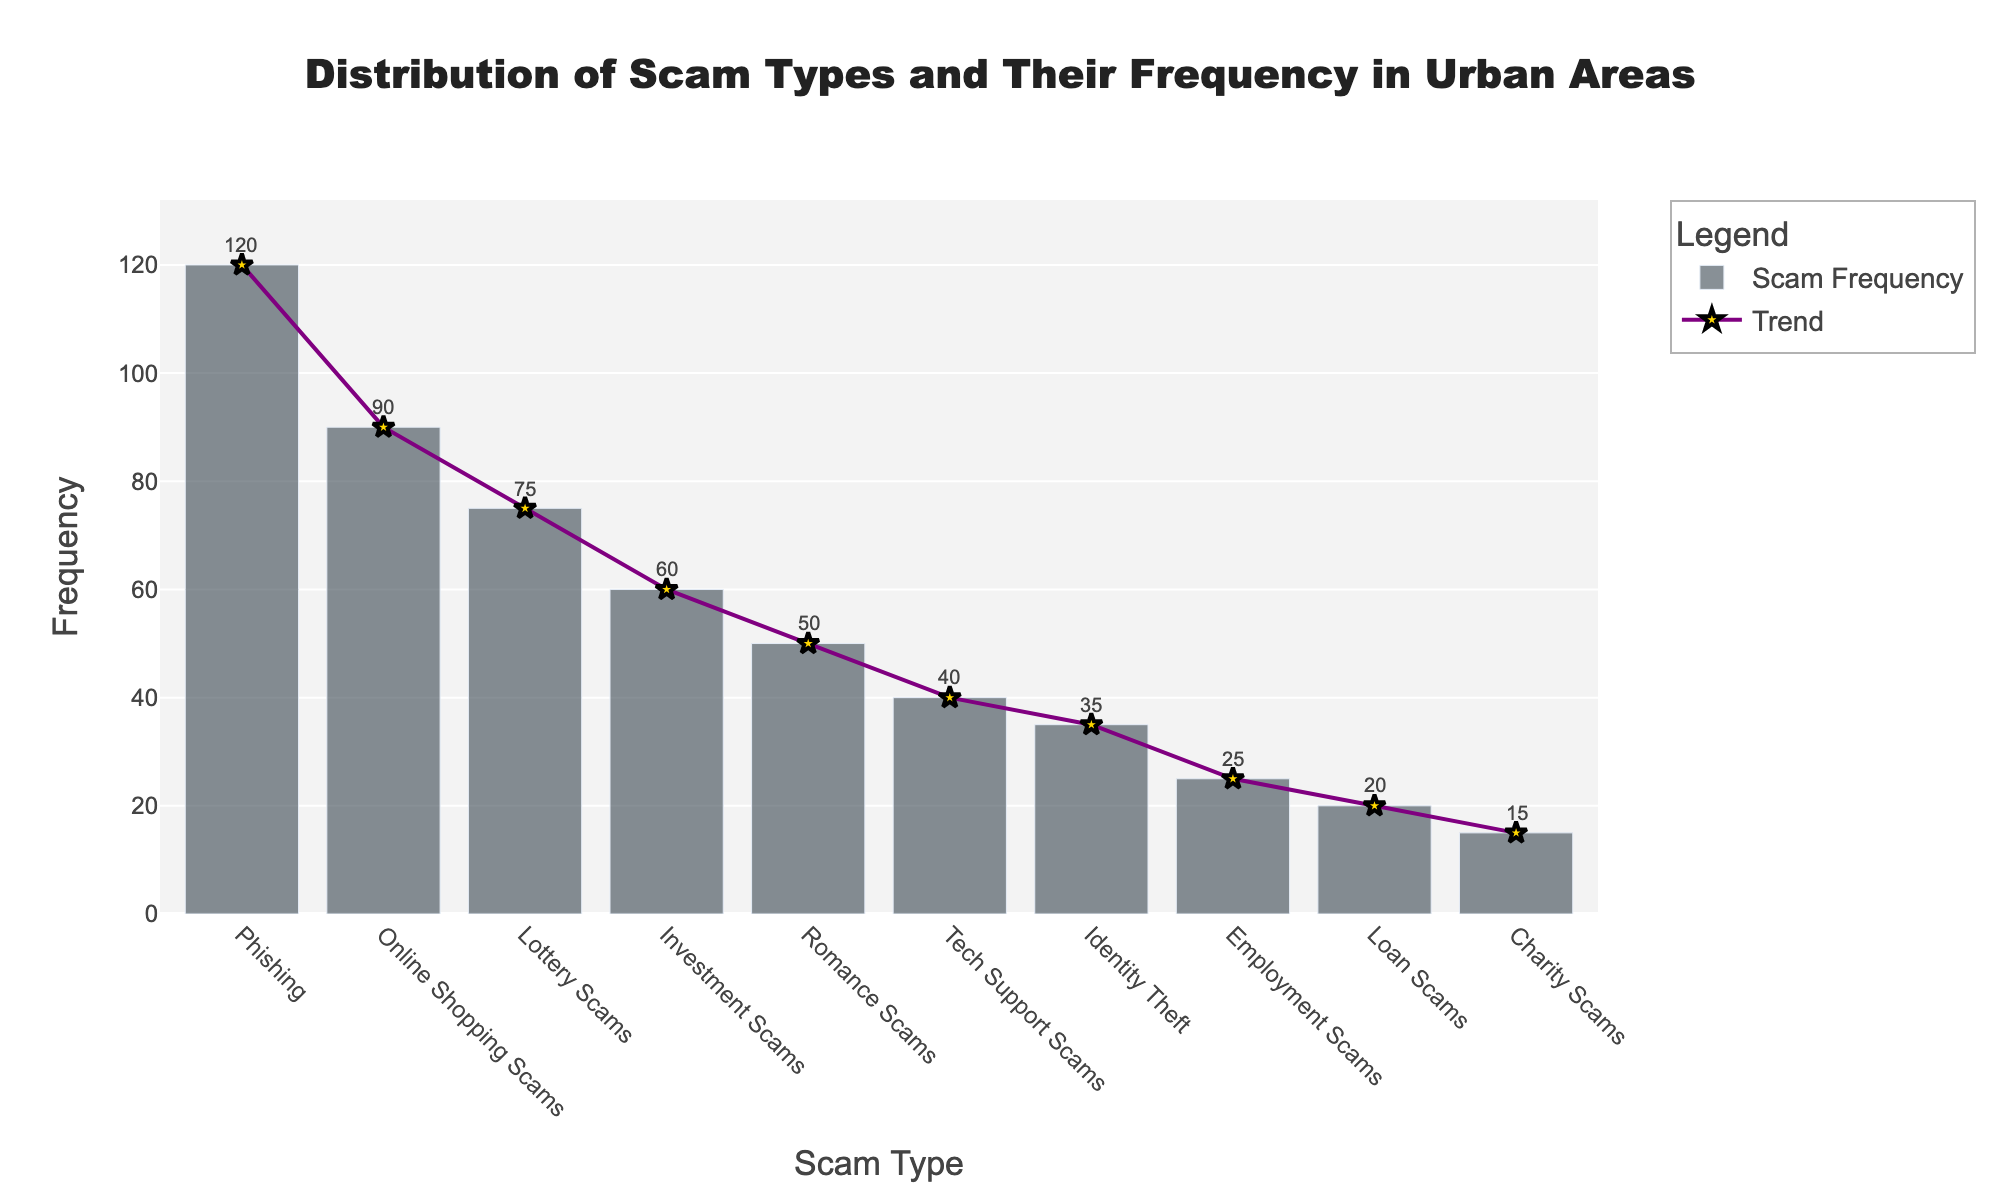what is the most frequent type of scam? The most frequent type of scam is indicated by the highest bar in the bar chart. The highest bar corresponds to 'Phishing', with a frequency of 120 cases.
Answer: Phishing which scam type has the least frequency? The scam type with the least frequency can be identified by the lowest bar in the bar chart. The lowest bar corresponds to 'Charity Scams', with a frequency of 15 cases.
Answer: Charity Scams how many scam types have a frequency higher than 60? Scan the bar chart for bars that are taller than the 60 mark on the y-axis. There are 4 scam types ('Phishing', 'Online Shopping Scams', 'Lottery Scams', and 'Investment Scams') with a frequency higher than 60.
Answer: 4 what is the combined frequency of 'Tech Support Scams' and 'Identity Theft'? Find the heights of the bars corresponding to 'Tech Support Scams' and 'Identity Theft'. 'Tech Support Scams' has a frequency of 40, and 'Identity Theft' has a frequency of 35. Summing these gives 40 + 35 = 75.
Answer: 75 Which scam type has a frequency exactly half of 'Phishing'? 'Phishing' has a frequency of 120. The type of scam with half this frequency (120/2 = 60) is 'Investment Scams'.
Answer: Investment Scams How does the frequency of 'Romance Scams' compare to 'Lottery Scams'? The bar chart indicates that 'Romance Scams' has a frequency of 50, while 'Lottery Scams' has a frequency of 75. Therefore, 'Romance Scams' has a lower frequency than 'Lottery Scams'.
Answer: Lower Is the frequency of 'Loan Scams' closer to 'Charity Scams' or 'Employment Scams'? The frequency of 'Loan Scams' is 20. The frequency of 'Charity Scams' is 15, and the frequency of 'Employment Scams' is 25. The difference between 'Loan Scams' and 'Charity Scams' is 5 (20 - 15), and the difference between 'Loan Scams' and 'Employment Scams' is also 5 (25 - 20). Therefore, 'Loan Scams' is equally close to both 'Charity Scams' and 'Employment Scams'.
Answer: Equally close What is the average frequency of all scam types? Sum the frequencies of all scam types: 120 + 90 + 75 + 60 + 50 + 40 + 35 + 25 + 20 + 15 = 530. There are 10 scam types, so the average frequency is 530 / 10 = 53.
Answer: 53 What is the trend of the data points as illustrated by the scatter plot with lines and markers? The scatter plot shows the individual data points with a connecting line. The general trend appears to descend from left to right, indicating that scam types with higher frequencies tend to be on the left side of the plot while those with lower frequencies tend to be on the right side.
Answer: Descending 